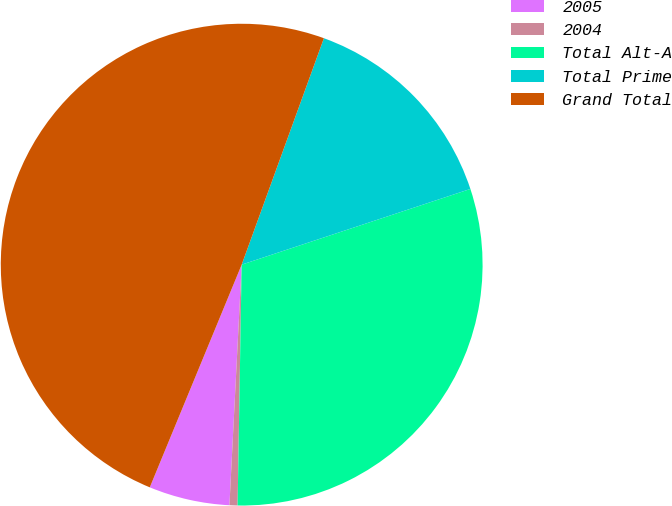Convert chart to OTSL. <chart><loc_0><loc_0><loc_500><loc_500><pie_chart><fcel>2005<fcel>2004<fcel>Total Alt-A<fcel>Total Prime<fcel>Grand Total<nl><fcel>5.42%<fcel>0.54%<fcel>30.36%<fcel>14.37%<fcel>49.32%<nl></chart> 